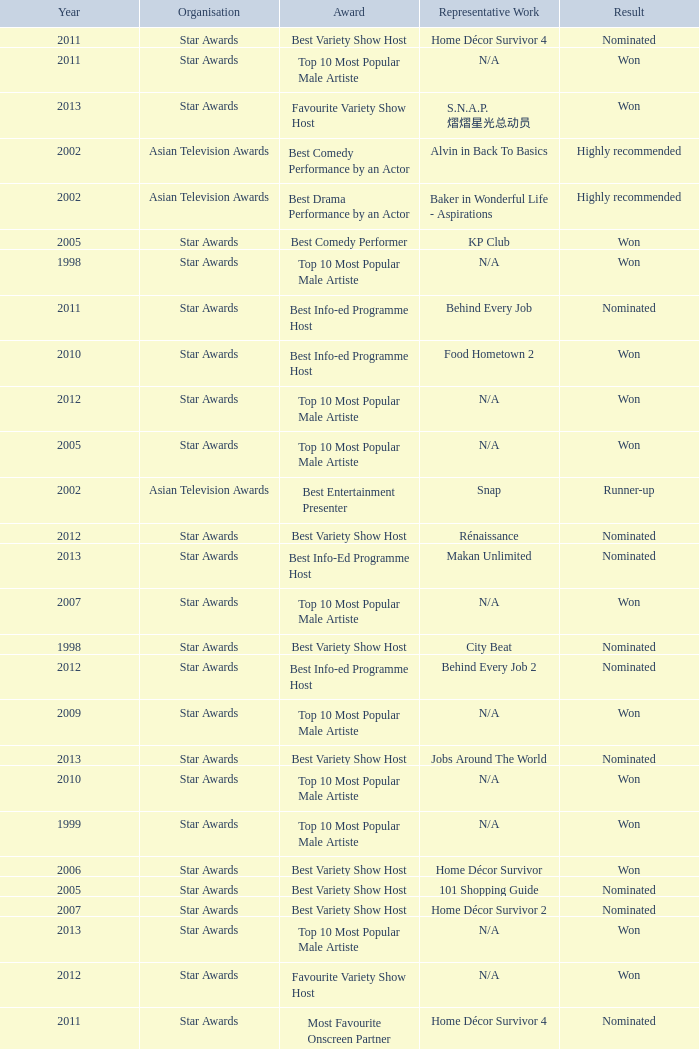What is the name of the Representative Work in a year later than 2005 with a Result of nominated, and an Award of best variety show host? Home Décor Survivor 2, Home Décor Survivor 4, Rénaissance, Jobs Around The World. 